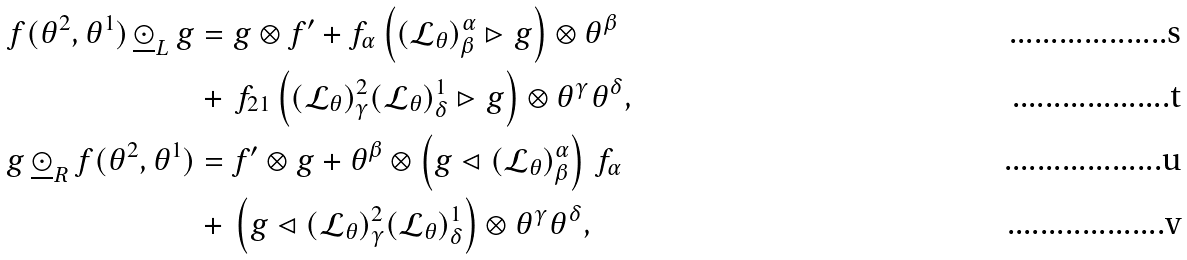Convert formula to latex. <formula><loc_0><loc_0><loc_500><loc_500>f ( \theta ^ { 2 } , \theta ^ { 1 } ) \, \underline { \odot } _ { L } \, g & = g \otimes f ^ { \prime } + f _ { \alpha } \left ( ( \mathcal { L } _ { \theta } ) _ { \beta } ^ { \alpha } \rhd g \right ) \otimes \theta ^ { \beta } \\ & + \, f _ { 2 1 } \left ( ( \mathcal { L } _ { \theta } ) _ { \gamma } ^ { 2 } ( \mathcal { L } _ { \theta } ) _ { \delta } ^ { 1 } \rhd g \right ) \otimes \theta ^ { \gamma } \theta ^ { \delta } , \\ g \, \underline { \odot } _ { R } \, f ( \theta ^ { 2 } , \theta ^ { 1 } ) & = f ^ { \prime } \otimes g + \theta ^ { \beta } \otimes \left ( g \lhd ( \mathcal { L } _ { \theta } ) _ { \beta } ^ { \alpha } \right ) \, f _ { \alpha } \\ & + \, \left ( g \lhd ( \mathcal { L } _ { \theta } ) _ { \gamma } ^ { 2 } ( \mathcal { L } _ { \theta } ) _ { \delta } ^ { 1 } \right ) \otimes \theta ^ { \gamma } \theta ^ { \delta } ,</formula> 